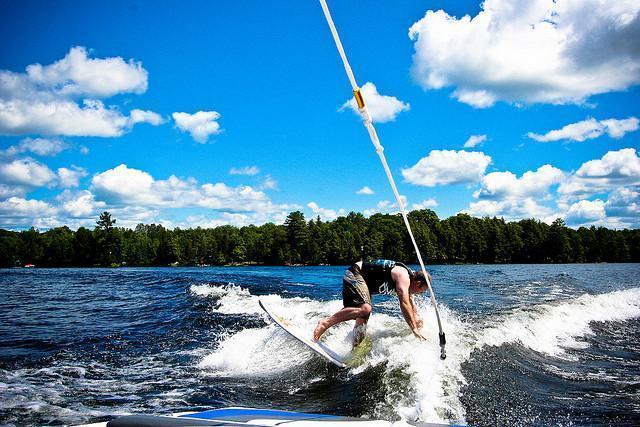How many people are in  the  water?
Give a very brief answer. 1. 